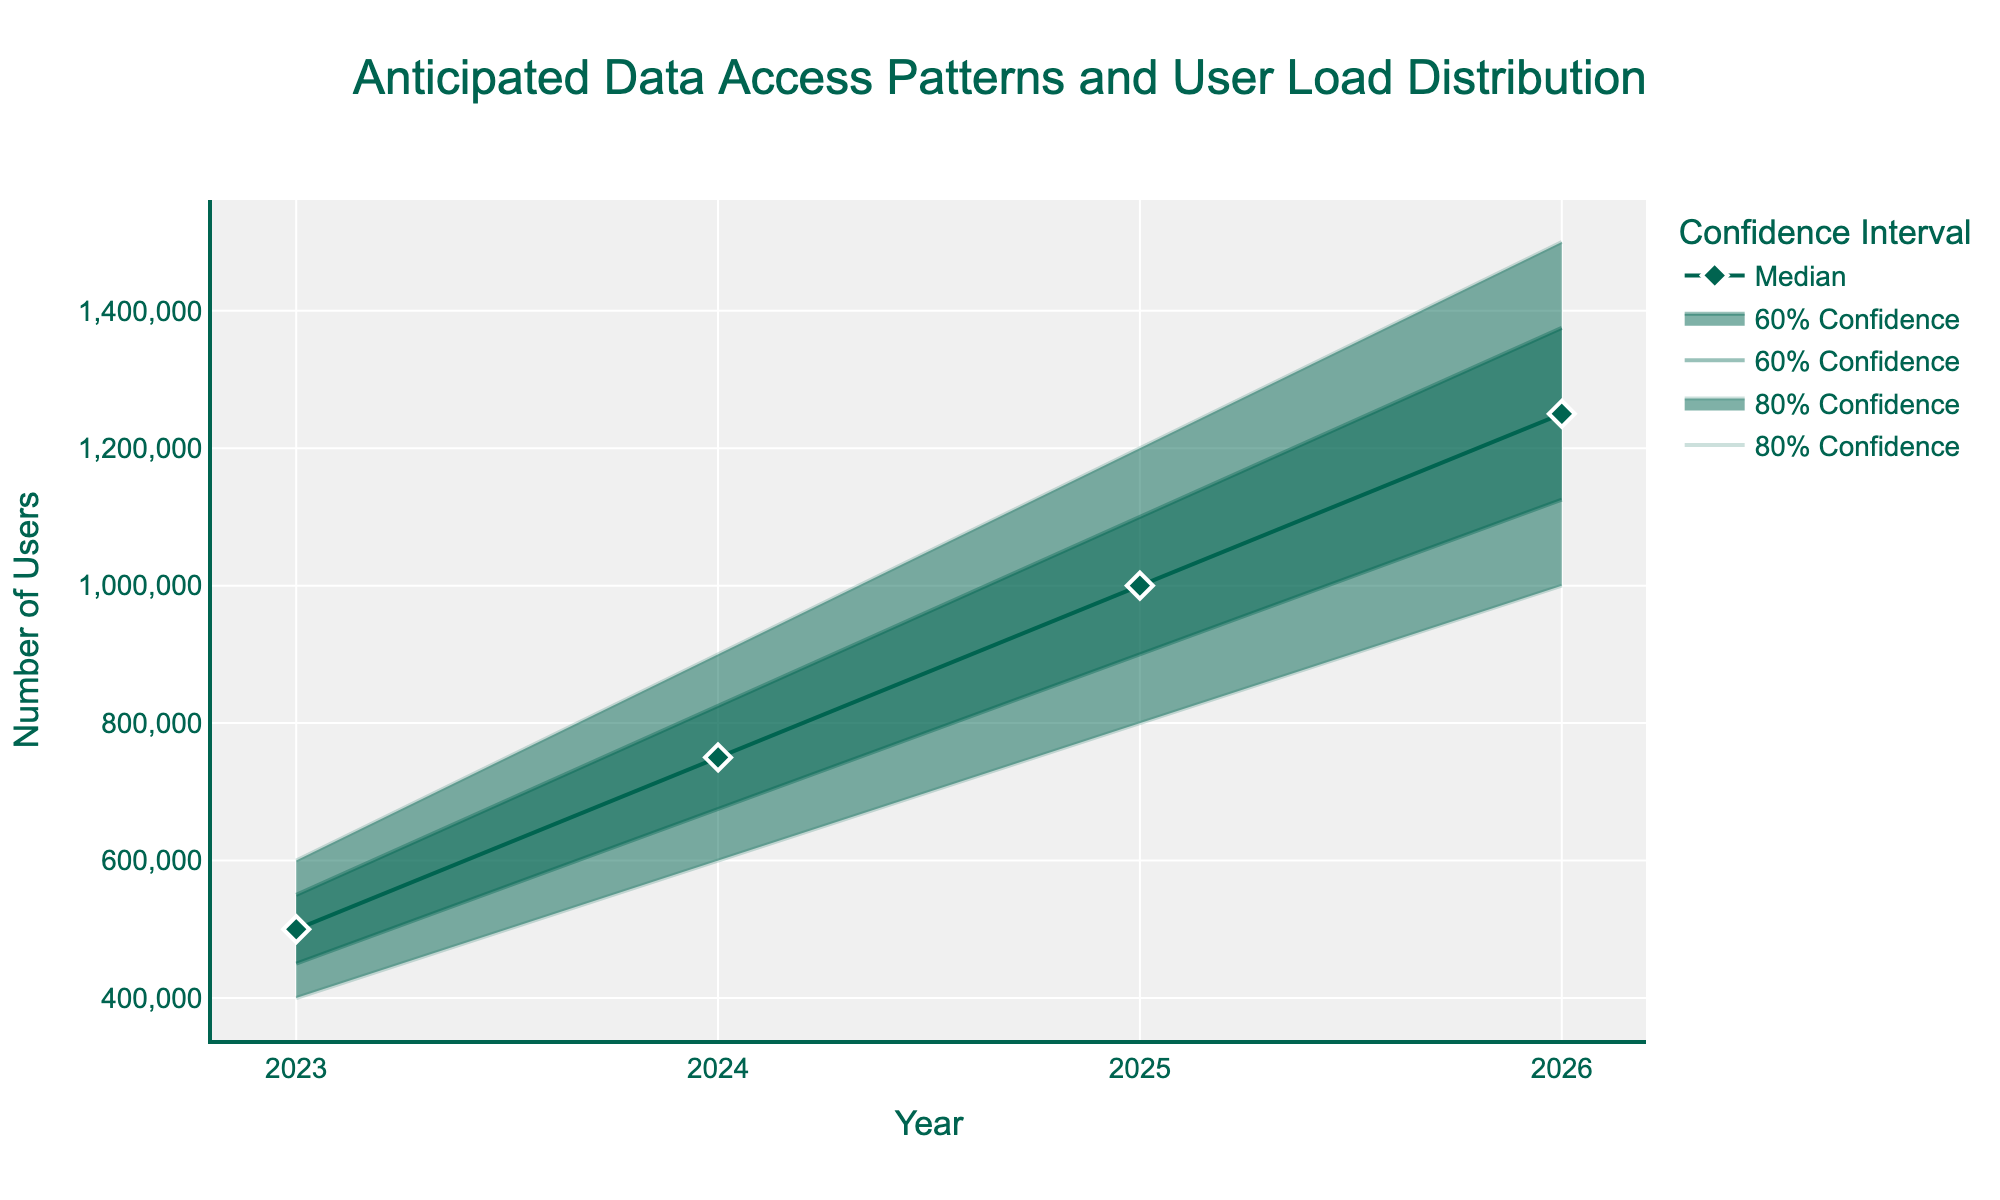what is the total number of years covered in the chart? The x-axis denotes the years covered by the chart. From the first data point in 2023 to the last data point in 2026, there are a total of 4 years.
Answer: 4 What is the title of the chart? The title is located at the top of the chart and reads "Anticipated Data Access Patterns and User Load Distribution".
Answer: Anticipated Data Access Patterns and User Load Distribution What is the median number of users anticipated in 2025? The median number of users is represented by the line with markers. For the year 2025, the median value is 1,000,000.
Answer: 1,000,000 What is the range of the 80% confidence interval for the year 2024? The 80% confidence interval spans from the lower 20% value to the upper 20% value. For 2024, this range is from 600,000 to 900,000.
Answer: 600,000 to 900,000 By how much is the median number of users expected to increase from 2023 to 2026? To find the increase, subtract the median value in 2023 from the median value in 2026: 1,250,000 - 500,000 = 750,000
Answer: 750,000 Which year shows the smallest difference between the upper 10% and lower 10% values? Subtract the lower 10% value from the upper 10% value for each year. The differences are as follows: 2023: 100,000, 2024: 150,000, 2025: 200,000, 2026: 250,000. The smallest difference is in 2023.
Answer: 2023 How does the 60% confidence interval width change from 2023 to 2026? The width of the 60% confidence interval is the difference between the upper 10% and lower 10% values. Comparing the years: 2023: 100,000, 2024: 150,000, 2025: 200,000, 2026: 250,000. This shows a consistent increase over the years.
Answer: Increases What is the color used for the median line on the chart? The median line is represented in the color green.
Answer: Green What is the upper limit of the 80% confidence interval in 2025? For 2025, the upper limit of the 80% confidence interval is the upper 20% value. This value is 1,200,000.
Answer: 1,200,000 